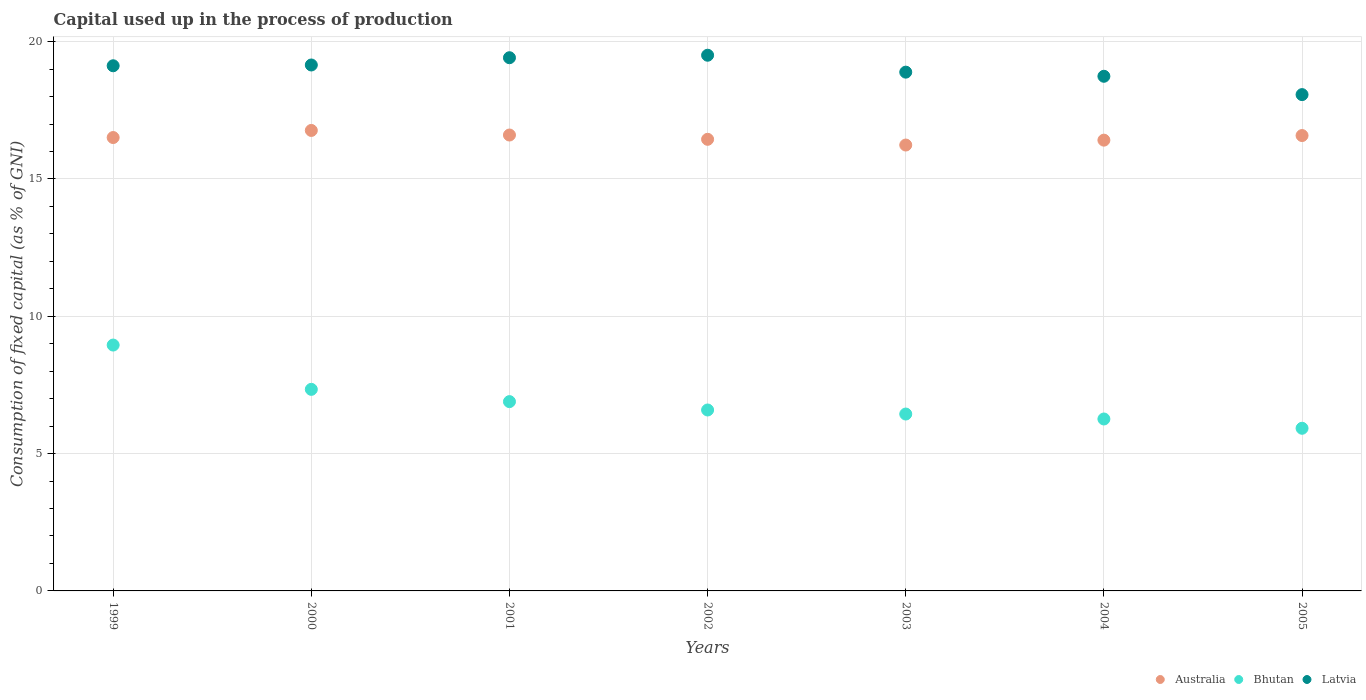Is the number of dotlines equal to the number of legend labels?
Provide a short and direct response. Yes. What is the capital used up in the process of production in Latvia in 2001?
Give a very brief answer. 19.42. Across all years, what is the maximum capital used up in the process of production in Bhutan?
Ensure brevity in your answer.  8.95. Across all years, what is the minimum capital used up in the process of production in Bhutan?
Offer a terse response. 5.92. What is the total capital used up in the process of production in Latvia in the graph?
Give a very brief answer. 132.9. What is the difference between the capital used up in the process of production in Bhutan in 2001 and that in 2005?
Make the answer very short. 0.97. What is the difference between the capital used up in the process of production in Australia in 2003 and the capital used up in the process of production in Bhutan in 1999?
Your response must be concise. 7.28. What is the average capital used up in the process of production in Latvia per year?
Your answer should be compact. 18.99. In the year 2001, what is the difference between the capital used up in the process of production in Latvia and capital used up in the process of production in Australia?
Your response must be concise. 2.81. What is the ratio of the capital used up in the process of production in Bhutan in 1999 to that in 2003?
Ensure brevity in your answer.  1.39. Is the difference between the capital used up in the process of production in Latvia in 1999 and 2001 greater than the difference between the capital used up in the process of production in Australia in 1999 and 2001?
Provide a short and direct response. No. What is the difference between the highest and the second highest capital used up in the process of production in Bhutan?
Give a very brief answer. 1.61. What is the difference between the highest and the lowest capital used up in the process of production in Latvia?
Offer a very short reply. 1.43. Is the sum of the capital used up in the process of production in Bhutan in 1999 and 2005 greater than the maximum capital used up in the process of production in Latvia across all years?
Keep it short and to the point. No. Is it the case that in every year, the sum of the capital used up in the process of production in Latvia and capital used up in the process of production in Bhutan  is greater than the capital used up in the process of production in Australia?
Make the answer very short. Yes. Is the capital used up in the process of production in Latvia strictly greater than the capital used up in the process of production in Bhutan over the years?
Your response must be concise. Yes. Is the capital used up in the process of production in Bhutan strictly less than the capital used up in the process of production in Australia over the years?
Your answer should be compact. Yes. How many years are there in the graph?
Give a very brief answer. 7. What is the difference between two consecutive major ticks on the Y-axis?
Keep it short and to the point. 5. Are the values on the major ticks of Y-axis written in scientific E-notation?
Keep it short and to the point. No. Does the graph contain any zero values?
Make the answer very short. No. Where does the legend appear in the graph?
Offer a terse response. Bottom right. What is the title of the graph?
Your answer should be compact. Capital used up in the process of production. Does "Yemen, Rep." appear as one of the legend labels in the graph?
Provide a short and direct response. No. What is the label or title of the Y-axis?
Your answer should be very brief. Consumption of fixed capital (as % of GNI). What is the Consumption of fixed capital (as % of GNI) of Australia in 1999?
Give a very brief answer. 16.51. What is the Consumption of fixed capital (as % of GNI) of Bhutan in 1999?
Make the answer very short. 8.95. What is the Consumption of fixed capital (as % of GNI) of Latvia in 1999?
Your response must be concise. 19.12. What is the Consumption of fixed capital (as % of GNI) of Australia in 2000?
Offer a very short reply. 16.77. What is the Consumption of fixed capital (as % of GNI) in Bhutan in 2000?
Offer a very short reply. 7.34. What is the Consumption of fixed capital (as % of GNI) in Latvia in 2000?
Your answer should be very brief. 19.15. What is the Consumption of fixed capital (as % of GNI) in Australia in 2001?
Your answer should be compact. 16.6. What is the Consumption of fixed capital (as % of GNI) of Bhutan in 2001?
Your response must be concise. 6.89. What is the Consumption of fixed capital (as % of GNI) of Latvia in 2001?
Provide a succinct answer. 19.42. What is the Consumption of fixed capital (as % of GNI) of Australia in 2002?
Your response must be concise. 16.45. What is the Consumption of fixed capital (as % of GNI) in Bhutan in 2002?
Your response must be concise. 6.59. What is the Consumption of fixed capital (as % of GNI) of Latvia in 2002?
Your answer should be compact. 19.51. What is the Consumption of fixed capital (as % of GNI) of Australia in 2003?
Your answer should be very brief. 16.24. What is the Consumption of fixed capital (as % of GNI) in Bhutan in 2003?
Give a very brief answer. 6.44. What is the Consumption of fixed capital (as % of GNI) in Latvia in 2003?
Give a very brief answer. 18.89. What is the Consumption of fixed capital (as % of GNI) in Australia in 2004?
Your answer should be compact. 16.41. What is the Consumption of fixed capital (as % of GNI) of Bhutan in 2004?
Give a very brief answer. 6.26. What is the Consumption of fixed capital (as % of GNI) in Latvia in 2004?
Ensure brevity in your answer.  18.74. What is the Consumption of fixed capital (as % of GNI) of Australia in 2005?
Your response must be concise. 16.58. What is the Consumption of fixed capital (as % of GNI) in Bhutan in 2005?
Offer a very short reply. 5.92. What is the Consumption of fixed capital (as % of GNI) in Latvia in 2005?
Your answer should be compact. 18.07. Across all years, what is the maximum Consumption of fixed capital (as % of GNI) in Australia?
Provide a succinct answer. 16.77. Across all years, what is the maximum Consumption of fixed capital (as % of GNI) in Bhutan?
Ensure brevity in your answer.  8.95. Across all years, what is the maximum Consumption of fixed capital (as % of GNI) of Latvia?
Your answer should be very brief. 19.51. Across all years, what is the minimum Consumption of fixed capital (as % of GNI) of Australia?
Make the answer very short. 16.24. Across all years, what is the minimum Consumption of fixed capital (as % of GNI) in Bhutan?
Make the answer very short. 5.92. Across all years, what is the minimum Consumption of fixed capital (as % of GNI) of Latvia?
Your answer should be compact. 18.07. What is the total Consumption of fixed capital (as % of GNI) of Australia in the graph?
Give a very brief answer. 115.56. What is the total Consumption of fixed capital (as % of GNI) of Bhutan in the graph?
Your answer should be compact. 48.4. What is the total Consumption of fixed capital (as % of GNI) of Latvia in the graph?
Your answer should be compact. 132.9. What is the difference between the Consumption of fixed capital (as % of GNI) of Australia in 1999 and that in 2000?
Give a very brief answer. -0.26. What is the difference between the Consumption of fixed capital (as % of GNI) in Bhutan in 1999 and that in 2000?
Make the answer very short. 1.61. What is the difference between the Consumption of fixed capital (as % of GNI) of Latvia in 1999 and that in 2000?
Your response must be concise. -0.03. What is the difference between the Consumption of fixed capital (as % of GNI) in Australia in 1999 and that in 2001?
Make the answer very short. -0.09. What is the difference between the Consumption of fixed capital (as % of GNI) in Bhutan in 1999 and that in 2001?
Your response must be concise. 2.06. What is the difference between the Consumption of fixed capital (as % of GNI) in Latvia in 1999 and that in 2001?
Offer a very short reply. -0.29. What is the difference between the Consumption of fixed capital (as % of GNI) of Australia in 1999 and that in 2002?
Provide a succinct answer. 0.06. What is the difference between the Consumption of fixed capital (as % of GNI) in Bhutan in 1999 and that in 2002?
Give a very brief answer. 2.36. What is the difference between the Consumption of fixed capital (as % of GNI) in Latvia in 1999 and that in 2002?
Make the answer very short. -0.38. What is the difference between the Consumption of fixed capital (as % of GNI) of Australia in 1999 and that in 2003?
Your answer should be compact. 0.27. What is the difference between the Consumption of fixed capital (as % of GNI) of Bhutan in 1999 and that in 2003?
Keep it short and to the point. 2.51. What is the difference between the Consumption of fixed capital (as % of GNI) of Latvia in 1999 and that in 2003?
Your answer should be compact. 0.23. What is the difference between the Consumption of fixed capital (as % of GNI) of Australia in 1999 and that in 2004?
Offer a very short reply. 0.1. What is the difference between the Consumption of fixed capital (as % of GNI) in Bhutan in 1999 and that in 2004?
Ensure brevity in your answer.  2.69. What is the difference between the Consumption of fixed capital (as % of GNI) of Latvia in 1999 and that in 2004?
Ensure brevity in your answer.  0.38. What is the difference between the Consumption of fixed capital (as % of GNI) in Australia in 1999 and that in 2005?
Your response must be concise. -0.07. What is the difference between the Consumption of fixed capital (as % of GNI) in Bhutan in 1999 and that in 2005?
Give a very brief answer. 3.03. What is the difference between the Consumption of fixed capital (as % of GNI) in Latvia in 1999 and that in 2005?
Your response must be concise. 1.05. What is the difference between the Consumption of fixed capital (as % of GNI) in Australia in 2000 and that in 2001?
Offer a very short reply. 0.17. What is the difference between the Consumption of fixed capital (as % of GNI) in Bhutan in 2000 and that in 2001?
Give a very brief answer. 0.45. What is the difference between the Consumption of fixed capital (as % of GNI) in Latvia in 2000 and that in 2001?
Keep it short and to the point. -0.26. What is the difference between the Consumption of fixed capital (as % of GNI) in Australia in 2000 and that in 2002?
Offer a very short reply. 0.32. What is the difference between the Consumption of fixed capital (as % of GNI) in Bhutan in 2000 and that in 2002?
Your answer should be very brief. 0.75. What is the difference between the Consumption of fixed capital (as % of GNI) in Latvia in 2000 and that in 2002?
Ensure brevity in your answer.  -0.36. What is the difference between the Consumption of fixed capital (as % of GNI) in Australia in 2000 and that in 2003?
Ensure brevity in your answer.  0.53. What is the difference between the Consumption of fixed capital (as % of GNI) in Bhutan in 2000 and that in 2003?
Make the answer very short. 0.9. What is the difference between the Consumption of fixed capital (as % of GNI) in Latvia in 2000 and that in 2003?
Keep it short and to the point. 0.26. What is the difference between the Consumption of fixed capital (as % of GNI) of Australia in 2000 and that in 2004?
Your response must be concise. 0.35. What is the difference between the Consumption of fixed capital (as % of GNI) of Bhutan in 2000 and that in 2004?
Make the answer very short. 1.08. What is the difference between the Consumption of fixed capital (as % of GNI) of Latvia in 2000 and that in 2004?
Ensure brevity in your answer.  0.41. What is the difference between the Consumption of fixed capital (as % of GNI) of Australia in 2000 and that in 2005?
Your answer should be very brief. 0.19. What is the difference between the Consumption of fixed capital (as % of GNI) in Bhutan in 2000 and that in 2005?
Give a very brief answer. 1.42. What is the difference between the Consumption of fixed capital (as % of GNI) in Latvia in 2000 and that in 2005?
Your answer should be compact. 1.08. What is the difference between the Consumption of fixed capital (as % of GNI) in Australia in 2001 and that in 2002?
Keep it short and to the point. 0.16. What is the difference between the Consumption of fixed capital (as % of GNI) of Bhutan in 2001 and that in 2002?
Offer a terse response. 0.3. What is the difference between the Consumption of fixed capital (as % of GNI) of Latvia in 2001 and that in 2002?
Give a very brief answer. -0.09. What is the difference between the Consumption of fixed capital (as % of GNI) in Australia in 2001 and that in 2003?
Give a very brief answer. 0.36. What is the difference between the Consumption of fixed capital (as % of GNI) of Bhutan in 2001 and that in 2003?
Your response must be concise. 0.45. What is the difference between the Consumption of fixed capital (as % of GNI) in Latvia in 2001 and that in 2003?
Your answer should be compact. 0.53. What is the difference between the Consumption of fixed capital (as % of GNI) of Australia in 2001 and that in 2004?
Ensure brevity in your answer.  0.19. What is the difference between the Consumption of fixed capital (as % of GNI) of Bhutan in 2001 and that in 2004?
Offer a very short reply. 0.63. What is the difference between the Consumption of fixed capital (as % of GNI) of Latvia in 2001 and that in 2004?
Offer a terse response. 0.68. What is the difference between the Consumption of fixed capital (as % of GNI) of Australia in 2001 and that in 2005?
Make the answer very short. 0.02. What is the difference between the Consumption of fixed capital (as % of GNI) in Bhutan in 2001 and that in 2005?
Make the answer very short. 0.97. What is the difference between the Consumption of fixed capital (as % of GNI) in Latvia in 2001 and that in 2005?
Keep it short and to the point. 1.34. What is the difference between the Consumption of fixed capital (as % of GNI) of Australia in 2002 and that in 2003?
Offer a terse response. 0.21. What is the difference between the Consumption of fixed capital (as % of GNI) in Bhutan in 2002 and that in 2003?
Provide a short and direct response. 0.15. What is the difference between the Consumption of fixed capital (as % of GNI) of Latvia in 2002 and that in 2003?
Make the answer very short. 0.62. What is the difference between the Consumption of fixed capital (as % of GNI) in Australia in 2002 and that in 2004?
Give a very brief answer. 0.03. What is the difference between the Consumption of fixed capital (as % of GNI) of Bhutan in 2002 and that in 2004?
Provide a succinct answer. 0.33. What is the difference between the Consumption of fixed capital (as % of GNI) of Latvia in 2002 and that in 2004?
Offer a terse response. 0.77. What is the difference between the Consumption of fixed capital (as % of GNI) of Australia in 2002 and that in 2005?
Give a very brief answer. -0.14. What is the difference between the Consumption of fixed capital (as % of GNI) of Bhutan in 2002 and that in 2005?
Provide a succinct answer. 0.67. What is the difference between the Consumption of fixed capital (as % of GNI) of Latvia in 2002 and that in 2005?
Keep it short and to the point. 1.43. What is the difference between the Consumption of fixed capital (as % of GNI) of Australia in 2003 and that in 2004?
Make the answer very short. -0.18. What is the difference between the Consumption of fixed capital (as % of GNI) in Bhutan in 2003 and that in 2004?
Ensure brevity in your answer.  0.18. What is the difference between the Consumption of fixed capital (as % of GNI) of Latvia in 2003 and that in 2004?
Your answer should be very brief. 0.15. What is the difference between the Consumption of fixed capital (as % of GNI) in Australia in 2003 and that in 2005?
Provide a short and direct response. -0.35. What is the difference between the Consumption of fixed capital (as % of GNI) in Bhutan in 2003 and that in 2005?
Ensure brevity in your answer.  0.52. What is the difference between the Consumption of fixed capital (as % of GNI) in Latvia in 2003 and that in 2005?
Offer a very short reply. 0.82. What is the difference between the Consumption of fixed capital (as % of GNI) of Australia in 2004 and that in 2005?
Your answer should be compact. -0.17. What is the difference between the Consumption of fixed capital (as % of GNI) in Bhutan in 2004 and that in 2005?
Make the answer very short. 0.34. What is the difference between the Consumption of fixed capital (as % of GNI) of Latvia in 2004 and that in 2005?
Give a very brief answer. 0.67. What is the difference between the Consumption of fixed capital (as % of GNI) of Australia in 1999 and the Consumption of fixed capital (as % of GNI) of Bhutan in 2000?
Your answer should be compact. 9.17. What is the difference between the Consumption of fixed capital (as % of GNI) of Australia in 1999 and the Consumption of fixed capital (as % of GNI) of Latvia in 2000?
Provide a succinct answer. -2.64. What is the difference between the Consumption of fixed capital (as % of GNI) in Bhutan in 1999 and the Consumption of fixed capital (as % of GNI) in Latvia in 2000?
Provide a succinct answer. -10.2. What is the difference between the Consumption of fixed capital (as % of GNI) of Australia in 1999 and the Consumption of fixed capital (as % of GNI) of Bhutan in 2001?
Your answer should be very brief. 9.62. What is the difference between the Consumption of fixed capital (as % of GNI) in Australia in 1999 and the Consumption of fixed capital (as % of GNI) in Latvia in 2001?
Ensure brevity in your answer.  -2.91. What is the difference between the Consumption of fixed capital (as % of GNI) of Bhutan in 1999 and the Consumption of fixed capital (as % of GNI) of Latvia in 2001?
Offer a very short reply. -10.46. What is the difference between the Consumption of fixed capital (as % of GNI) in Australia in 1999 and the Consumption of fixed capital (as % of GNI) in Bhutan in 2002?
Offer a terse response. 9.92. What is the difference between the Consumption of fixed capital (as % of GNI) of Australia in 1999 and the Consumption of fixed capital (as % of GNI) of Latvia in 2002?
Your answer should be compact. -3. What is the difference between the Consumption of fixed capital (as % of GNI) in Bhutan in 1999 and the Consumption of fixed capital (as % of GNI) in Latvia in 2002?
Offer a very short reply. -10.55. What is the difference between the Consumption of fixed capital (as % of GNI) of Australia in 1999 and the Consumption of fixed capital (as % of GNI) of Bhutan in 2003?
Provide a succinct answer. 10.07. What is the difference between the Consumption of fixed capital (as % of GNI) in Australia in 1999 and the Consumption of fixed capital (as % of GNI) in Latvia in 2003?
Provide a short and direct response. -2.38. What is the difference between the Consumption of fixed capital (as % of GNI) of Bhutan in 1999 and the Consumption of fixed capital (as % of GNI) of Latvia in 2003?
Give a very brief answer. -9.94. What is the difference between the Consumption of fixed capital (as % of GNI) of Australia in 1999 and the Consumption of fixed capital (as % of GNI) of Bhutan in 2004?
Keep it short and to the point. 10.25. What is the difference between the Consumption of fixed capital (as % of GNI) in Australia in 1999 and the Consumption of fixed capital (as % of GNI) in Latvia in 2004?
Your answer should be very brief. -2.23. What is the difference between the Consumption of fixed capital (as % of GNI) in Bhutan in 1999 and the Consumption of fixed capital (as % of GNI) in Latvia in 2004?
Your answer should be compact. -9.79. What is the difference between the Consumption of fixed capital (as % of GNI) of Australia in 1999 and the Consumption of fixed capital (as % of GNI) of Bhutan in 2005?
Your response must be concise. 10.59. What is the difference between the Consumption of fixed capital (as % of GNI) of Australia in 1999 and the Consumption of fixed capital (as % of GNI) of Latvia in 2005?
Provide a succinct answer. -1.56. What is the difference between the Consumption of fixed capital (as % of GNI) in Bhutan in 1999 and the Consumption of fixed capital (as % of GNI) in Latvia in 2005?
Offer a terse response. -9.12. What is the difference between the Consumption of fixed capital (as % of GNI) of Australia in 2000 and the Consumption of fixed capital (as % of GNI) of Bhutan in 2001?
Make the answer very short. 9.87. What is the difference between the Consumption of fixed capital (as % of GNI) of Australia in 2000 and the Consumption of fixed capital (as % of GNI) of Latvia in 2001?
Keep it short and to the point. -2.65. What is the difference between the Consumption of fixed capital (as % of GNI) of Bhutan in 2000 and the Consumption of fixed capital (as % of GNI) of Latvia in 2001?
Make the answer very short. -12.08. What is the difference between the Consumption of fixed capital (as % of GNI) in Australia in 2000 and the Consumption of fixed capital (as % of GNI) in Bhutan in 2002?
Give a very brief answer. 10.18. What is the difference between the Consumption of fixed capital (as % of GNI) of Australia in 2000 and the Consumption of fixed capital (as % of GNI) of Latvia in 2002?
Your answer should be very brief. -2.74. What is the difference between the Consumption of fixed capital (as % of GNI) of Bhutan in 2000 and the Consumption of fixed capital (as % of GNI) of Latvia in 2002?
Keep it short and to the point. -12.17. What is the difference between the Consumption of fixed capital (as % of GNI) in Australia in 2000 and the Consumption of fixed capital (as % of GNI) in Bhutan in 2003?
Keep it short and to the point. 10.33. What is the difference between the Consumption of fixed capital (as % of GNI) of Australia in 2000 and the Consumption of fixed capital (as % of GNI) of Latvia in 2003?
Your answer should be compact. -2.12. What is the difference between the Consumption of fixed capital (as % of GNI) in Bhutan in 2000 and the Consumption of fixed capital (as % of GNI) in Latvia in 2003?
Provide a succinct answer. -11.55. What is the difference between the Consumption of fixed capital (as % of GNI) in Australia in 2000 and the Consumption of fixed capital (as % of GNI) in Bhutan in 2004?
Provide a succinct answer. 10.51. What is the difference between the Consumption of fixed capital (as % of GNI) of Australia in 2000 and the Consumption of fixed capital (as % of GNI) of Latvia in 2004?
Offer a very short reply. -1.97. What is the difference between the Consumption of fixed capital (as % of GNI) in Bhutan in 2000 and the Consumption of fixed capital (as % of GNI) in Latvia in 2004?
Provide a succinct answer. -11.4. What is the difference between the Consumption of fixed capital (as % of GNI) in Australia in 2000 and the Consumption of fixed capital (as % of GNI) in Bhutan in 2005?
Provide a succinct answer. 10.85. What is the difference between the Consumption of fixed capital (as % of GNI) of Australia in 2000 and the Consumption of fixed capital (as % of GNI) of Latvia in 2005?
Offer a very short reply. -1.3. What is the difference between the Consumption of fixed capital (as % of GNI) in Bhutan in 2000 and the Consumption of fixed capital (as % of GNI) in Latvia in 2005?
Your answer should be compact. -10.73. What is the difference between the Consumption of fixed capital (as % of GNI) of Australia in 2001 and the Consumption of fixed capital (as % of GNI) of Bhutan in 2002?
Provide a succinct answer. 10.01. What is the difference between the Consumption of fixed capital (as % of GNI) in Australia in 2001 and the Consumption of fixed capital (as % of GNI) in Latvia in 2002?
Give a very brief answer. -2.91. What is the difference between the Consumption of fixed capital (as % of GNI) of Bhutan in 2001 and the Consumption of fixed capital (as % of GNI) of Latvia in 2002?
Offer a terse response. -12.61. What is the difference between the Consumption of fixed capital (as % of GNI) of Australia in 2001 and the Consumption of fixed capital (as % of GNI) of Bhutan in 2003?
Keep it short and to the point. 10.16. What is the difference between the Consumption of fixed capital (as % of GNI) of Australia in 2001 and the Consumption of fixed capital (as % of GNI) of Latvia in 2003?
Make the answer very short. -2.29. What is the difference between the Consumption of fixed capital (as % of GNI) in Bhutan in 2001 and the Consumption of fixed capital (as % of GNI) in Latvia in 2003?
Ensure brevity in your answer.  -12. What is the difference between the Consumption of fixed capital (as % of GNI) of Australia in 2001 and the Consumption of fixed capital (as % of GNI) of Bhutan in 2004?
Make the answer very short. 10.34. What is the difference between the Consumption of fixed capital (as % of GNI) in Australia in 2001 and the Consumption of fixed capital (as % of GNI) in Latvia in 2004?
Your response must be concise. -2.14. What is the difference between the Consumption of fixed capital (as % of GNI) of Bhutan in 2001 and the Consumption of fixed capital (as % of GNI) of Latvia in 2004?
Provide a succinct answer. -11.85. What is the difference between the Consumption of fixed capital (as % of GNI) in Australia in 2001 and the Consumption of fixed capital (as % of GNI) in Bhutan in 2005?
Make the answer very short. 10.68. What is the difference between the Consumption of fixed capital (as % of GNI) of Australia in 2001 and the Consumption of fixed capital (as % of GNI) of Latvia in 2005?
Keep it short and to the point. -1.47. What is the difference between the Consumption of fixed capital (as % of GNI) in Bhutan in 2001 and the Consumption of fixed capital (as % of GNI) in Latvia in 2005?
Offer a terse response. -11.18. What is the difference between the Consumption of fixed capital (as % of GNI) in Australia in 2002 and the Consumption of fixed capital (as % of GNI) in Bhutan in 2003?
Your answer should be very brief. 10. What is the difference between the Consumption of fixed capital (as % of GNI) of Australia in 2002 and the Consumption of fixed capital (as % of GNI) of Latvia in 2003?
Your answer should be compact. -2.45. What is the difference between the Consumption of fixed capital (as % of GNI) in Bhutan in 2002 and the Consumption of fixed capital (as % of GNI) in Latvia in 2003?
Provide a short and direct response. -12.3. What is the difference between the Consumption of fixed capital (as % of GNI) in Australia in 2002 and the Consumption of fixed capital (as % of GNI) in Bhutan in 2004?
Provide a short and direct response. 10.18. What is the difference between the Consumption of fixed capital (as % of GNI) in Australia in 2002 and the Consumption of fixed capital (as % of GNI) in Latvia in 2004?
Your answer should be compact. -2.3. What is the difference between the Consumption of fixed capital (as % of GNI) of Bhutan in 2002 and the Consumption of fixed capital (as % of GNI) of Latvia in 2004?
Give a very brief answer. -12.15. What is the difference between the Consumption of fixed capital (as % of GNI) in Australia in 2002 and the Consumption of fixed capital (as % of GNI) in Bhutan in 2005?
Provide a succinct answer. 10.52. What is the difference between the Consumption of fixed capital (as % of GNI) of Australia in 2002 and the Consumption of fixed capital (as % of GNI) of Latvia in 2005?
Your response must be concise. -1.63. What is the difference between the Consumption of fixed capital (as % of GNI) in Bhutan in 2002 and the Consumption of fixed capital (as % of GNI) in Latvia in 2005?
Ensure brevity in your answer.  -11.48. What is the difference between the Consumption of fixed capital (as % of GNI) in Australia in 2003 and the Consumption of fixed capital (as % of GNI) in Bhutan in 2004?
Make the answer very short. 9.98. What is the difference between the Consumption of fixed capital (as % of GNI) of Australia in 2003 and the Consumption of fixed capital (as % of GNI) of Latvia in 2004?
Your response must be concise. -2.5. What is the difference between the Consumption of fixed capital (as % of GNI) of Bhutan in 2003 and the Consumption of fixed capital (as % of GNI) of Latvia in 2004?
Your response must be concise. -12.3. What is the difference between the Consumption of fixed capital (as % of GNI) in Australia in 2003 and the Consumption of fixed capital (as % of GNI) in Bhutan in 2005?
Ensure brevity in your answer.  10.31. What is the difference between the Consumption of fixed capital (as % of GNI) in Australia in 2003 and the Consumption of fixed capital (as % of GNI) in Latvia in 2005?
Your answer should be compact. -1.84. What is the difference between the Consumption of fixed capital (as % of GNI) of Bhutan in 2003 and the Consumption of fixed capital (as % of GNI) of Latvia in 2005?
Offer a terse response. -11.63. What is the difference between the Consumption of fixed capital (as % of GNI) in Australia in 2004 and the Consumption of fixed capital (as % of GNI) in Bhutan in 2005?
Your response must be concise. 10.49. What is the difference between the Consumption of fixed capital (as % of GNI) of Australia in 2004 and the Consumption of fixed capital (as % of GNI) of Latvia in 2005?
Keep it short and to the point. -1.66. What is the difference between the Consumption of fixed capital (as % of GNI) in Bhutan in 2004 and the Consumption of fixed capital (as % of GNI) in Latvia in 2005?
Keep it short and to the point. -11.81. What is the average Consumption of fixed capital (as % of GNI) in Australia per year?
Offer a terse response. 16.51. What is the average Consumption of fixed capital (as % of GNI) of Bhutan per year?
Make the answer very short. 6.91. What is the average Consumption of fixed capital (as % of GNI) of Latvia per year?
Offer a terse response. 18.99. In the year 1999, what is the difference between the Consumption of fixed capital (as % of GNI) in Australia and Consumption of fixed capital (as % of GNI) in Bhutan?
Your response must be concise. 7.56. In the year 1999, what is the difference between the Consumption of fixed capital (as % of GNI) of Australia and Consumption of fixed capital (as % of GNI) of Latvia?
Your answer should be very brief. -2.61. In the year 1999, what is the difference between the Consumption of fixed capital (as % of GNI) of Bhutan and Consumption of fixed capital (as % of GNI) of Latvia?
Your answer should be compact. -10.17. In the year 2000, what is the difference between the Consumption of fixed capital (as % of GNI) of Australia and Consumption of fixed capital (as % of GNI) of Bhutan?
Your response must be concise. 9.43. In the year 2000, what is the difference between the Consumption of fixed capital (as % of GNI) in Australia and Consumption of fixed capital (as % of GNI) in Latvia?
Ensure brevity in your answer.  -2.38. In the year 2000, what is the difference between the Consumption of fixed capital (as % of GNI) of Bhutan and Consumption of fixed capital (as % of GNI) of Latvia?
Ensure brevity in your answer.  -11.81. In the year 2001, what is the difference between the Consumption of fixed capital (as % of GNI) in Australia and Consumption of fixed capital (as % of GNI) in Bhutan?
Your answer should be very brief. 9.71. In the year 2001, what is the difference between the Consumption of fixed capital (as % of GNI) in Australia and Consumption of fixed capital (as % of GNI) in Latvia?
Offer a terse response. -2.81. In the year 2001, what is the difference between the Consumption of fixed capital (as % of GNI) in Bhutan and Consumption of fixed capital (as % of GNI) in Latvia?
Your answer should be compact. -12.52. In the year 2002, what is the difference between the Consumption of fixed capital (as % of GNI) of Australia and Consumption of fixed capital (as % of GNI) of Bhutan?
Your answer should be very brief. 9.86. In the year 2002, what is the difference between the Consumption of fixed capital (as % of GNI) in Australia and Consumption of fixed capital (as % of GNI) in Latvia?
Your answer should be compact. -3.06. In the year 2002, what is the difference between the Consumption of fixed capital (as % of GNI) in Bhutan and Consumption of fixed capital (as % of GNI) in Latvia?
Your answer should be compact. -12.92. In the year 2003, what is the difference between the Consumption of fixed capital (as % of GNI) of Australia and Consumption of fixed capital (as % of GNI) of Bhutan?
Provide a short and direct response. 9.8. In the year 2003, what is the difference between the Consumption of fixed capital (as % of GNI) of Australia and Consumption of fixed capital (as % of GNI) of Latvia?
Make the answer very short. -2.65. In the year 2003, what is the difference between the Consumption of fixed capital (as % of GNI) in Bhutan and Consumption of fixed capital (as % of GNI) in Latvia?
Offer a terse response. -12.45. In the year 2004, what is the difference between the Consumption of fixed capital (as % of GNI) in Australia and Consumption of fixed capital (as % of GNI) in Bhutan?
Ensure brevity in your answer.  10.15. In the year 2004, what is the difference between the Consumption of fixed capital (as % of GNI) of Australia and Consumption of fixed capital (as % of GNI) of Latvia?
Provide a short and direct response. -2.33. In the year 2004, what is the difference between the Consumption of fixed capital (as % of GNI) of Bhutan and Consumption of fixed capital (as % of GNI) of Latvia?
Your answer should be very brief. -12.48. In the year 2005, what is the difference between the Consumption of fixed capital (as % of GNI) of Australia and Consumption of fixed capital (as % of GNI) of Bhutan?
Provide a succinct answer. 10.66. In the year 2005, what is the difference between the Consumption of fixed capital (as % of GNI) in Australia and Consumption of fixed capital (as % of GNI) in Latvia?
Your answer should be very brief. -1.49. In the year 2005, what is the difference between the Consumption of fixed capital (as % of GNI) in Bhutan and Consumption of fixed capital (as % of GNI) in Latvia?
Make the answer very short. -12.15. What is the ratio of the Consumption of fixed capital (as % of GNI) of Australia in 1999 to that in 2000?
Provide a succinct answer. 0.98. What is the ratio of the Consumption of fixed capital (as % of GNI) of Bhutan in 1999 to that in 2000?
Ensure brevity in your answer.  1.22. What is the ratio of the Consumption of fixed capital (as % of GNI) of Australia in 1999 to that in 2001?
Provide a succinct answer. 0.99. What is the ratio of the Consumption of fixed capital (as % of GNI) in Bhutan in 1999 to that in 2001?
Your answer should be compact. 1.3. What is the ratio of the Consumption of fixed capital (as % of GNI) in Latvia in 1999 to that in 2001?
Your answer should be very brief. 0.98. What is the ratio of the Consumption of fixed capital (as % of GNI) in Australia in 1999 to that in 2002?
Give a very brief answer. 1. What is the ratio of the Consumption of fixed capital (as % of GNI) of Bhutan in 1999 to that in 2002?
Provide a short and direct response. 1.36. What is the ratio of the Consumption of fixed capital (as % of GNI) in Latvia in 1999 to that in 2002?
Your answer should be compact. 0.98. What is the ratio of the Consumption of fixed capital (as % of GNI) in Australia in 1999 to that in 2003?
Keep it short and to the point. 1.02. What is the ratio of the Consumption of fixed capital (as % of GNI) in Bhutan in 1999 to that in 2003?
Offer a very short reply. 1.39. What is the ratio of the Consumption of fixed capital (as % of GNI) of Latvia in 1999 to that in 2003?
Offer a very short reply. 1.01. What is the ratio of the Consumption of fixed capital (as % of GNI) in Australia in 1999 to that in 2004?
Make the answer very short. 1.01. What is the ratio of the Consumption of fixed capital (as % of GNI) in Bhutan in 1999 to that in 2004?
Provide a succinct answer. 1.43. What is the ratio of the Consumption of fixed capital (as % of GNI) of Latvia in 1999 to that in 2004?
Ensure brevity in your answer.  1.02. What is the ratio of the Consumption of fixed capital (as % of GNI) of Australia in 1999 to that in 2005?
Your response must be concise. 1. What is the ratio of the Consumption of fixed capital (as % of GNI) in Bhutan in 1999 to that in 2005?
Your response must be concise. 1.51. What is the ratio of the Consumption of fixed capital (as % of GNI) in Latvia in 1999 to that in 2005?
Offer a very short reply. 1.06. What is the ratio of the Consumption of fixed capital (as % of GNI) of Australia in 2000 to that in 2001?
Keep it short and to the point. 1.01. What is the ratio of the Consumption of fixed capital (as % of GNI) in Bhutan in 2000 to that in 2001?
Offer a very short reply. 1.06. What is the ratio of the Consumption of fixed capital (as % of GNI) in Latvia in 2000 to that in 2001?
Provide a short and direct response. 0.99. What is the ratio of the Consumption of fixed capital (as % of GNI) of Australia in 2000 to that in 2002?
Provide a succinct answer. 1.02. What is the ratio of the Consumption of fixed capital (as % of GNI) of Bhutan in 2000 to that in 2002?
Offer a terse response. 1.11. What is the ratio of the Consumption of fixed capital (as % of GNI) in Latvia in 2000 to that in 2002?
Your response must be concise. 0.98. What is the ratio of the Consumption of fixed capital (as % of GNI) of Australia in 2000 to that in 2003?
Your response must be concise. 1.03. What is the ratio of the Consumption of fixed capital (as % of GNI) in Bhutan in 2000 to that in 2003?
Provide a succinct answer. 1.14. What is the ratio of the Consumption of fixed capital (as % of GNI) in Latvia in 2000 to that in 2003?
Make the answer very short. 1.01. What is the ratio of the Consumption of fixed capital (as % of GNI) of Australia in 2000 to that in 2004?
Ensure brevity in your answer.  1.02. What is the ratio of the Consumption of fixed capital (as % of GNI) in Bhutan in 2000 to that in 2004?
Offer a terse response. 1.17. What is the ratio of the Consumption of fixed capital (as % of GNI) of Latvia in 2000 to that in 2004?
Give a very brief answer. 1.02. What is the ratio of the Consumption of fixed capital (as % of GNI) of Australia in 2000 to that in 2005?
Provide a succinct answer. 1.01. What is the ratio of the Consumption of fixed capital (as % of GNI) in Bhutan in 2000 to that in 2005?
Provide a short and direct response. 1.24. What is the ratio of the Consumption of fixed capital (as % of GNI) of Latvia in 2000 to that in 2005?
Ensure brevity in your answer.  1.06. What is the ratio of the Consumption of fixed capital (as % of GNI) of Australia in 2001 to that in 2002?
Make the answer very short. 1.01. What is the ratio of the Consumption of fixed capital (as % of GNI) in Bhutan in 2001 to that in 2002?
Keep it short and to the point. 1.05. What is the ratio of the Consumption of fixed capital (as % of GNI) of Latvia in 2001 to that in 2002?
Ensure brevity in your answer.  1. What is the ratio of the Consumption of fixed capital (as % of GNI) of Australia in 2001 to that in 2003?
Offer a very short reply. 1.02. What is the ratio of the Consumption of fixed capital (as % of GNI) of Bhutan in 2001 to that in 2003?
Offer a very short reply. 1.07. What is the ratio of the Consumption of fixed capital (as % of GNI) in Latvia in 2001 to that in 2003?
Provide a short and direct response. 1.03. What is the ratio of the Consumption of fixed capital (as % of GNI) of Australia in 2001 to that in 2004?
Your answer should be compact. 1.01. What is the ratio of the Consumption of fixed capital (as % of GNI) in Bhutan in 2001 to that in 2004?
Provide a succinct answer. 1.1. What is the ratio of the Consumption of fixed capital (as % of GNI) in Latvia in 2001 to that in 2004?
Make the answer very short. 1.04. What is the ratio of the Consumption of fixed capital (as % of GNI) in Bhutan in 2001 to that in 2005?
Offer a terse response. 1.16. What is the ratio of the Consumption of fixed capital (as % of GNI) of Latvia in 2001 to that in 2005?
Offer a very short reply. 1.07. What is the ratio of the Consumption of fixed capital (as % of GNI) in Australia in 2002 to that in 2003?
Provide a succinct answer. 1.01. What is the ratio of the Consumption of fixed capital (as % of GNI) of Bhutan in 2002 to that in 2003?
Provide a succinct answer. 1.02. What is the ratio of the Consumption of fixed capital (as % of GNI) of Latvia in 2002 to that in 2003?
Your answer should be compact. 1.03. What is the ratio of the Consumption of fixed capital (as % of GNI) in Bhutan in 2002 to that in 2004?
Provide a short and direct response. 1.05. What is the ratio of the Consumption of fixed capital (as % of GNI) in Latvia in 2002 to that in 2004?
Make the answer very short. 1.04. What is the ratio of the Consumption of fixed capital (as % of GNI) in Bhutan in 2002 to that in 2005?
Ensure brevity in your answer.  1.11. What is the ratio of the Consumption of fixed capital (as % of GNI) in Latvia in 2002 to that in 2005?
Your answer should be very brief. 1.08. What is the ratio of the Consumption of fixed capital (as % of GNI) of Bhutan in 2003 to that in 2004?
Give a very brief answer. 1.03. What is the ratio of the Consumption of fixed capital (as % of GNI) in Latvia in 2003 to that in 2004?
Your answer should be compact. 1.01. What is the ratio of the Consumption of fixed capital (as % of GNI) in Australia in 2003 to that in 2005?
Provide a succinct answer. 0.98. What is the ratio of the Consumption of fixed capital (as % of GNI) of Bhutan in 2003 to that in 2005?
Provide a succinct answer. 1.09. What is the ratio of the Consumption of fixed capital (as % of GNI) in Latvia in 2003 to that in 2005?
Provide a succinct answer. 1.05. What is the ratio of the Consumption of fixed capital (as % of GNI) in Bhutan in 2004 to that in 2005?
Provide a short and direct response. 1.06. What is the ratio of the Consumption of fixed capital (as % of GNI) in Latvia in 2004 to that in 2005?
Keep it short and to the point. 1.04. What is the difference between the highest and the second highest Consumption of fixed capital (as % of GNI) of Australia?
Offer a very short reply. 0.17. What is the difference between the highest and the second highest Consumption of fixed capital (as % of GNI) in Bhutan?
Keep it short and to the point. 1.61. What is the difference between the highest and the second highest Consumption of fixed capital (as % of GNI) in Latvia?
Offer a terse response. 0.09. What is the difference between the highest and the lowest Consumption of fixed capital (as % of GNI) in Australia?
Offer a very short reply. 0.53. What is the difference between the highest and the lowest Consumption of fixed capital (as % of GNI) of Bhutan?
Offer a very short reply. 3.03. What is the difference between the highest and the lowest Consumption of fixed capital (as % of GNI) of Latvia?
Offer a terse response. 1.43. 